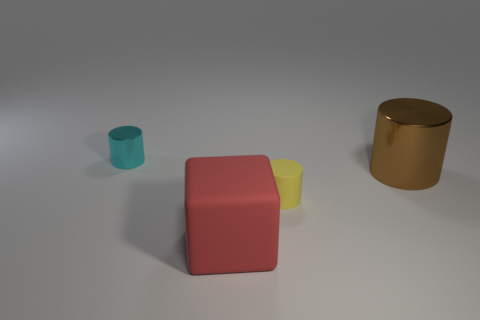Add 1 small yellow things. How many objects exist? 5 Subtract all cubes. How many objects are left? 3 Add 3 tiny yellow cylinders. How many tiny yellow cylinders are left? 4 Add 4 blue cylinders. How many blue cylinders exist? 4 Subtract 1 red cubes. How many objects are left? 3 Subtract all yellow rubber objects. Subtract all big brown cylinders. How many objects are left? 2 